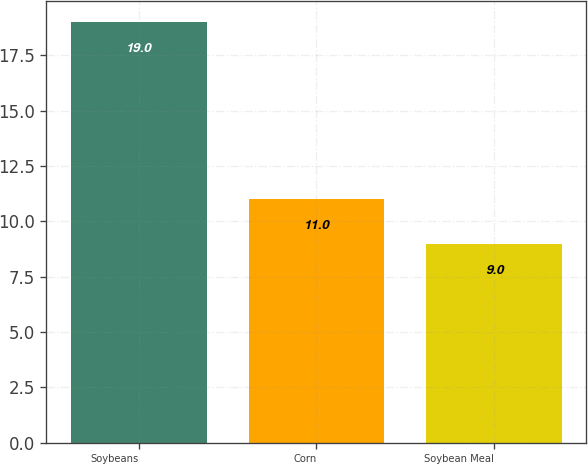Convert chart. <chart><loc_0><loc_0><loc_500><loc_500><bar_chart><fcel>Soybeans<fcel>Corn<fcel>Soybean Meal<nl><fcel>19<fcel>11<fcel>9<nl></chart> 